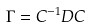Convert formula to latex. <formula><loc_0><loc_0><loc_500><loc_500>\Gamma = C ^ { - 1 } D C</formula> 